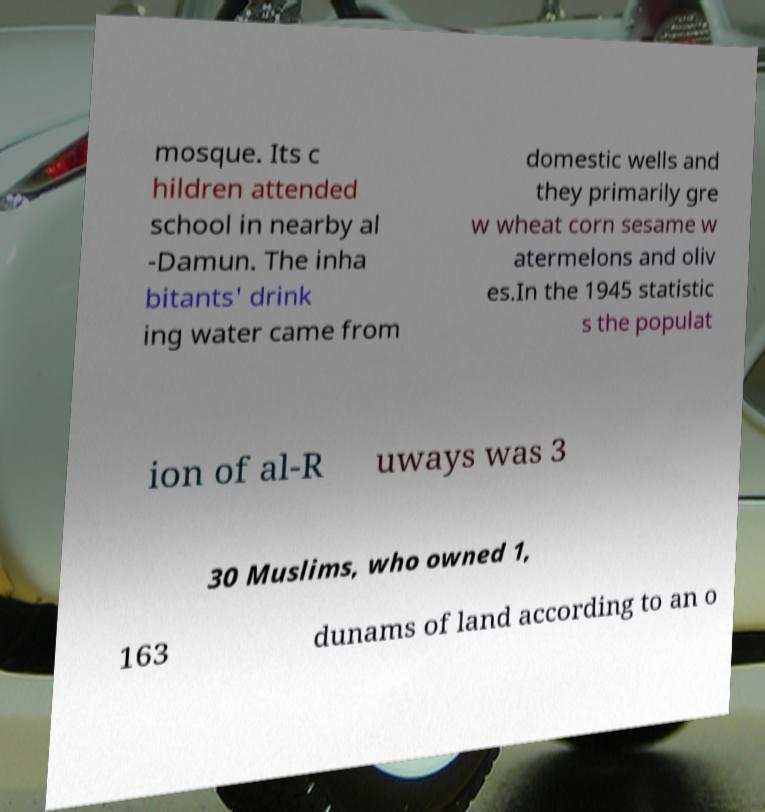Can you read and provide the text displayed in the image?This photo seems to have some interesting text. Can you extract and type it out for me? mosque. Its c hildren attended school in nearby al -Damun. The inha bitants' drink ing water came from domestic wells and they primarily gre w wheat corn sesame w atermelons and oliv es.In the 1945 statistic s the populat ion of al-R uways was 3 30 Muslims, who owned 1, 163 dunams of land according to an o 